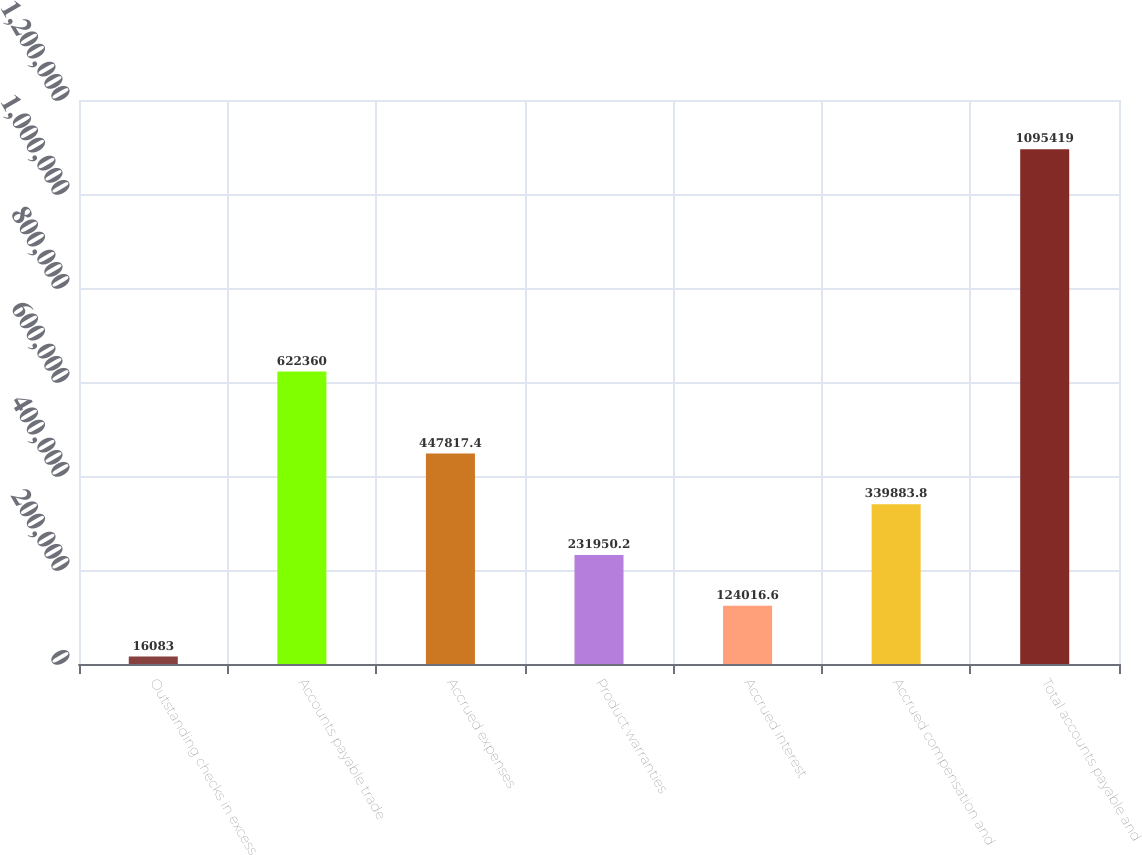Convert chart. <chart><loc_0><loc_0><loc_500><loc_500><bar_chart><fcel>Outstanding checks in excess<fcel>Accounts payable trade<fcel>Accrued expenses<fcel>Product warranties<fcel>Accrued interest<fcel>Accrued compensation and<fcel>Total accounts payable and<nl><fcel>16083<fcel>622360<fcel>447817<fcel>231950<fcel>124017<fcel>339884<fcel>1.09542e+06<nl></chart> 